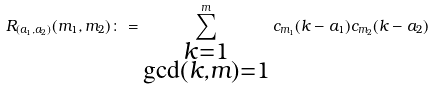Convert formula to latex. <formula><loc_0><loc_0><loc_500><loc_500>R _ { ( a _ { 1 } , a _ { 2 } ) } ( m _ { 1 } , m _ { 2 } ) \colon = \sum _ { \substack { k = 1 \\ \gcd ( k , m ) = 1 } } ^ { m } c _ { m _ { 1 } } ( k - a _ { 1 } ) c _ { m _ { 2 } } ( k - a _ { 2 } )</formula> 